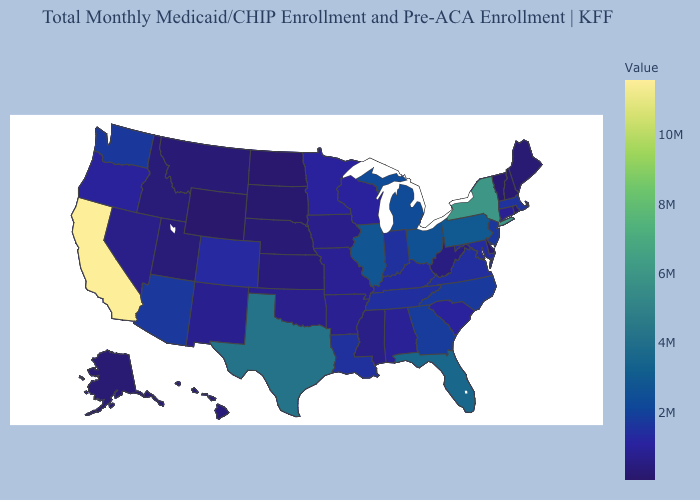Does West Virginia have the highest value in the South?
Concise answer only. No. Does the map have missing data?
Quick response, please. No. Which states have the lowest value in the USA?
Concise answer only. Wyoming. Does Massachusetts have the highest value in the Northeast?
Short answer required. No. Does Maine have a higher value than Louisiana?
Be succinct. No. Does Michigan have the highest value in the MidWest?
Give a very brief answer. No. Among the states that border Arkansas , does Louisiana have the lowest value?
Write a very short answer. No. Among the states that border Oklahoma , does Kansas have the lowest value?
Concise answer only. Yes. 